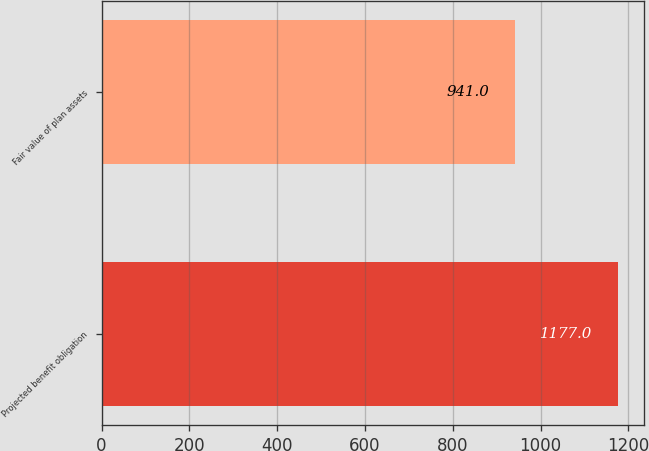Convert chart to OTSL. <chart><loc_0><loc_0><loc_500><loc_500><bar_chart><fcel>Projected benefit obligation<fcel>Fair value of plan assets<nl><fcel>1177<fcel>941<nl></chart> 